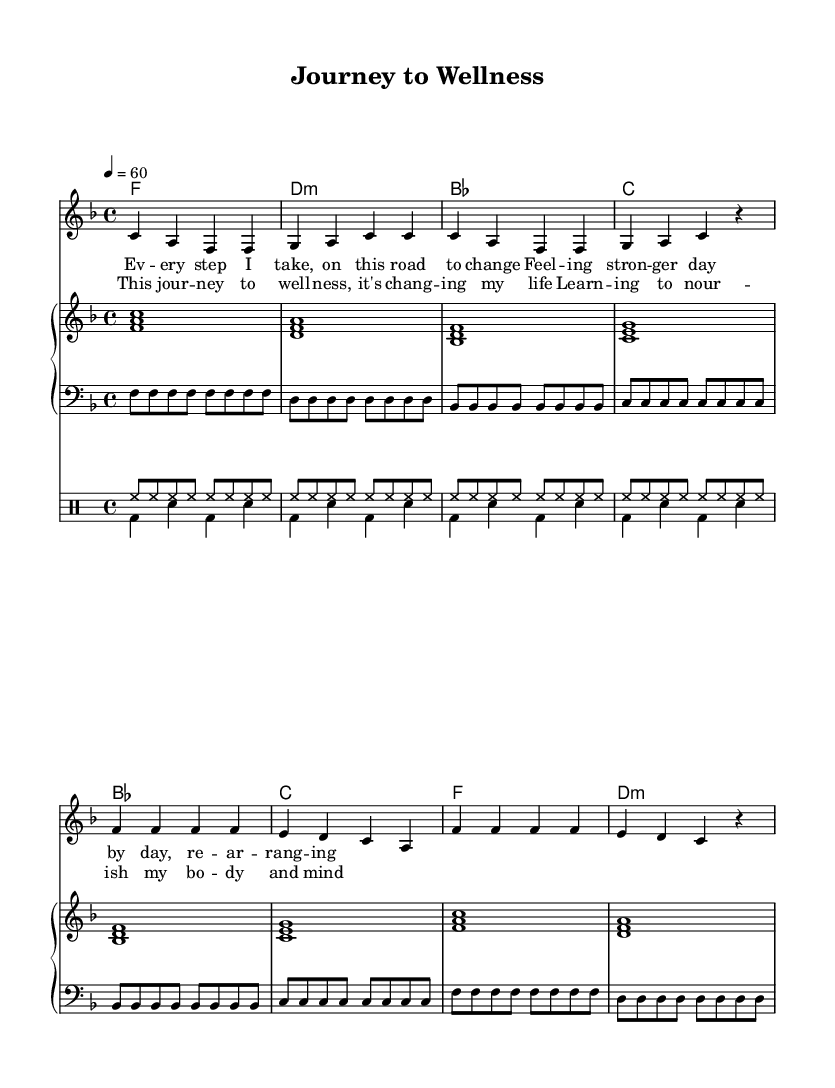What is the key signature of this music? The key signature is F major, which has one flat (B♭). It can be identified by looking at the beginning of the staff where the flat is indicated.
Answer: F major What is the time signature of this music? The time signature is 4/4, indicated at the beginning of the sheet music. This means there are four beats in each measure and a quarter note receives one beat.
Answer: 4/4 What is the tempo marking for this music? The tempo marking is 60 beats per minute, indicated by the "4 = 60" marking at the beginning. This means the quarter note is played at a speed of 60 beats per minute.
Answer: 60 How many measures are in the chorus? The chorus consists of two measures, clearly marked with the lyrics noted after the verse. These measures are identified by counting the length of the lyric lines associated with the chorus.
Answer: 2 What emotions does the lyrics convey in the verse? The lyrics in the verse express strength and resilience in the context of lifestyle changes, which aligns with the soulful ballad's themes of emotional impact. This can be inferred from the words chosen and the reflective nature of the lyrics.
Answer: Strength What is the function of the drum part in this composition? The drum part provides rhythmic support and enhances the soulful feel of the piece. The combination of hi-hat and bass drum creates a driving beat, which is crucial for maintaining the pulse in soulful ballads.
Answer: Rhythmic support What does the use of the word "journey" suggest in the lyrics? The word "journey" suggests a process of transformation and personal growth related to wellness. It indicates movement and progression towards a healthier lifestyle, resonating with the theme of the ballad.
Answer: Transformation 